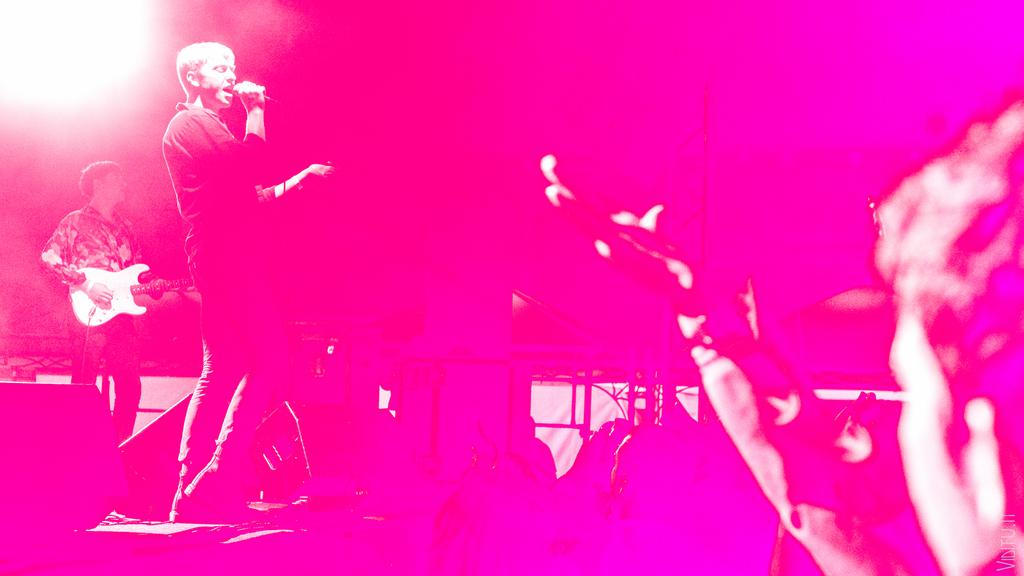How many people are in the image? There are people in the image. What are the people doing in the image? One person is holding a microphone and singing, while another person is holding a guitar and playing. What type of spot is visible on the brain of the person holding the microphone? There is no brain visible in the image, and therefore no spot can be observed. 